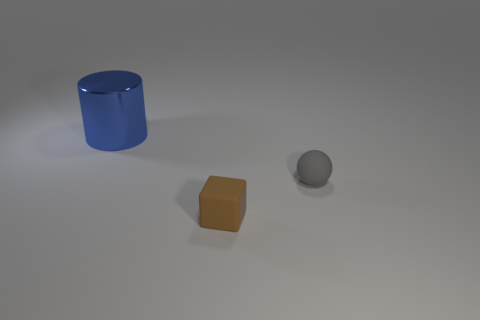What shape is the tiny object that is the same material as the small brown cube? sphere 